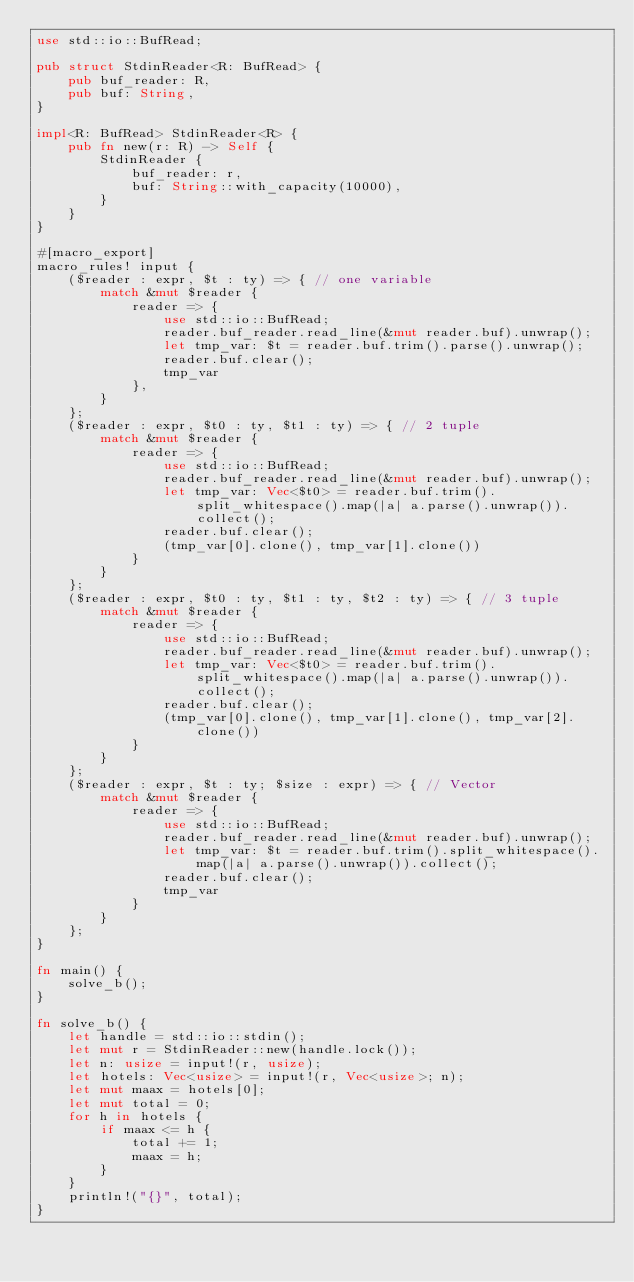Convert code to text. <code><loc_0><loc_0><loc_500><loc_500><_Rust_>use std::io::BufRead;

pub struct StdinReader<R: BufRead> {
    pub buf_reader: R,
    pub buf: String,
}

impl<R: BufRead> StdinReader<R> {
    pub fn new(r: R) -> Self {
        StdinReader {
            buf_reader: r,
            buf: String::with_capacity(10000),
        }
    }
}

#[macro_export]
macro_rules! input {
    ($reader : expr, $t : ty) => { // one variable
        match &mut $reader {
            reader => {
                use std::io::BufRead;
                reader.buf_reader.read_line(&mut reader.buf).unwrap();
                let tmp_var: $t = reader.buf.trim().parse().unwrap();
                reader.buf.clear();
                tmp_var
            },
        }
    };
    ($reader : expr, $t0 : ty, $t1 : ty) => { // 2 tuple
        match &mut $reader {
            reader => {
                use std::io::BufRead;
                reader.buf_reader.read_line(&mut reader.buf).unwrap();
                let tmp_var: Vec<$t0> = reader.buf.trim().split_whitespace().map(|a| a.parse().unwrap()).collect();
                reader.buf.clear();
                (tmp_var[0].clone(), tmp_var[1].clone())
            }
        }
    };
    ($reader : expr, $t0 : ty, $t1 : ty, $t2 : ty) => { // 3 tuple
        match &mut $reader {
            reader => {
                use std::io::BufRead;
                reader.buf_reader.read_line(&mut reader.buf).unwrap();
                let tmp_var: Vec<$t0> = reader.buf.trim().split_whitespace().map(|a| a.parse().unwrap()).collect();
                reader.buf.clear();
                (tmp_var[0].clone(), tmp_var[1].clone(), tmp_var[2].clone())
            }
        }
    };
    ($reader : expr, $t : ty; $size : expr) => { // Vector
        match &mut $reader {
            reader => {
                use std::io::BufRead;
                reader.buf_reader.read_line(&mut reader.buf).unwrap();
                let tmp_var: $t = reader.buf.trim().split_whitespace().map(|a| a.parse().unwrap()).collect();
                reader.buf.clear();
                tmp_var
            }
        }
    };
}

fn main() {
    solve_b();
}

fn solve_b() {
    let handle = std::io::stdin();
    let mut r = StdinReader::new(handle.lock());
    let n: usize = input!(r, usize);
    let hotels: Vec<usize> = input!(r, Vec<usize>; n);
    let mut maax = hotels[0];
    let mut total = 0;
    for h in hotels {
        if maax <= h {
            total += 1;
            maax = h;
        }
    }
    println!("{}", total);
}
</code> 